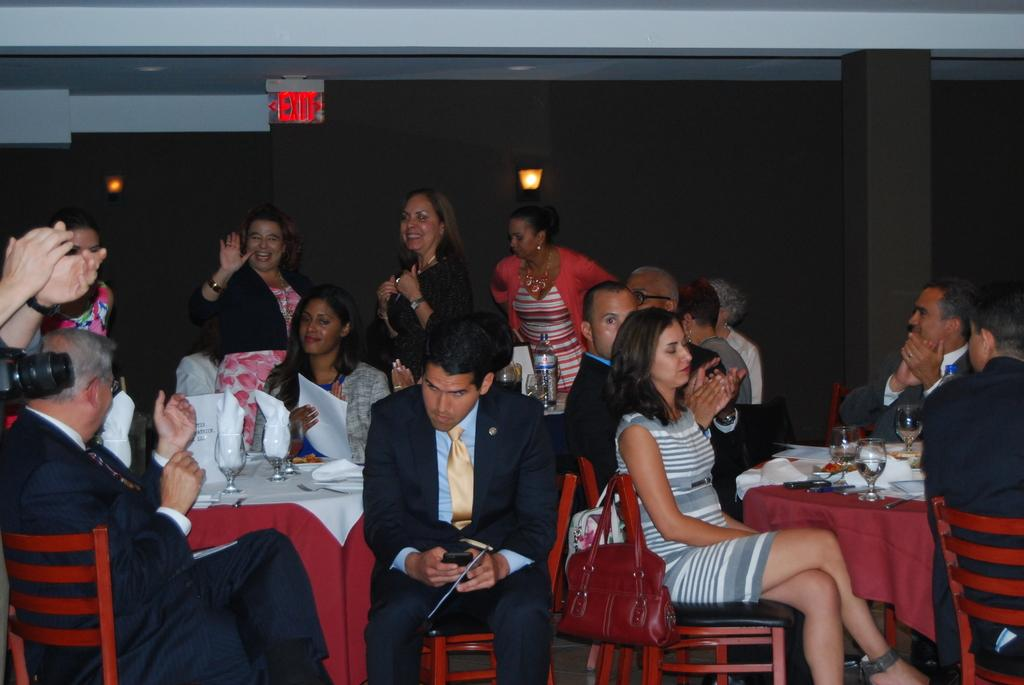<image>
Create a compact narrative representing the image presented. A lit up exit sign, that is lit up red. 